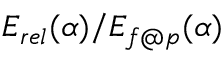<formula> <loc_0><loc_0><loc_500><loc_500>E _ { r e l } ( \alpha ) / E _ { f p } ( \alpha )</formula> 